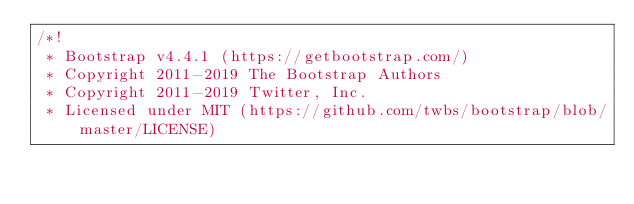<code> <loc_0><loc_0><loc_500><loc_500><_CSS_>/*!
 * Bootstrap v4.4.1 (https://getbootstrap.com/)
 * Copyright 2011-2019 The Bootstrap Authors
 * Copyright 2011-2019 Twitter, Inc.
 * Licensed under MIT (https://github.com/twbs/bootstrap/blob/master/LICENSE)</code> 